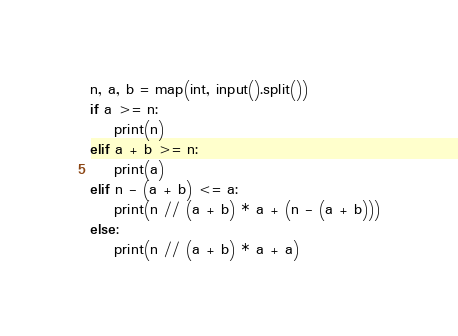<code> <loc_0><loc_0><loc_500><loc_500><_Python_>n, a, b = map(int, input().split())
if a >= n:
    print(n)
elif a + b >= n:
    print(a)
elif n - (a + b) <= a:
    print(n // (a + b) * a + (n - (a + b)))
else:
    print(n // (a + b) * a + a)</code> 